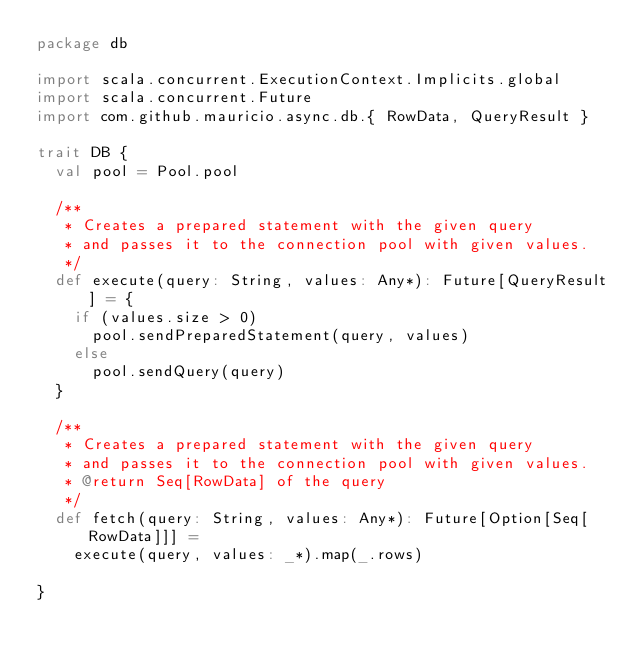Convert code to text. <code><loc_0><loc_0><loc_500><loc_500><_Scala_>package db

import scala.concurrent.ExecutionContext.Implicits.global
import scala.concurrent.Future
import com.github.mauricio.async.db.{ RowData, QueryResult }

trait DB {
  val pool = Pool.pool

  /**
   * Creates a prepared statement with the given query
   * and passes it to the connection pool with given values.
   */
  def execute(query: String, values: Any*): Future[QueryResult] = {
    if (values.size > 0)
      pool.sendPreparedStatement(query, values)
    else
      pool.sendQuery(query)
  }

  /**
   * Creates a prepared statement with the given query
   * and passes it to the connection pool with given values.
   * @return Seq[RowData] of the query
   */
  def fetch(query: String, values: Any*): Future[Option[Seq[RowData]]] =
    execute(query, values: _*).map(_.rows)

}
</code> 